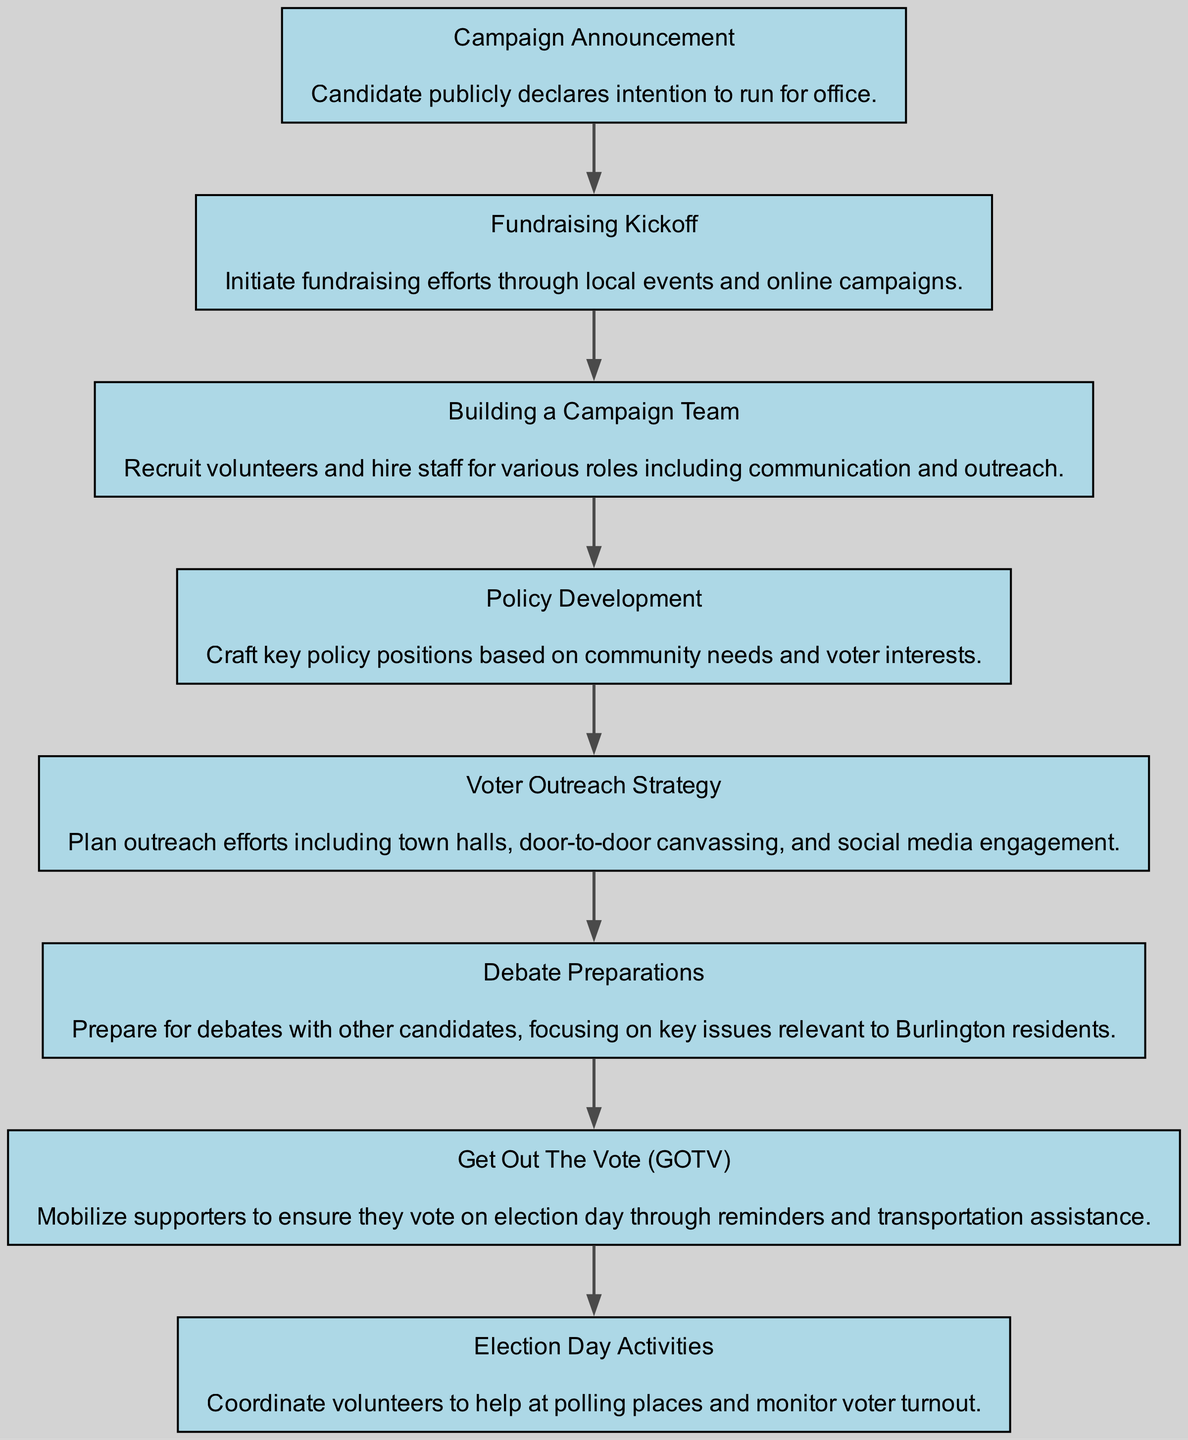What is the first stage in the campaign progression? The first stage listed in the diagram is "Campaign Announcement", which indicates the initial public declaration of the candidate's intention to run for office.
Answer: Campaign Announcement How many total stages are represented in the flow chart? By counting each stage from "Campaign Announcement" to "Election Day Activities," there are eight distinct stages shown in the diagram.
Answer: 8 What follows "Fundraising Kickoff" in the progression? The stage that comes immediately after "Fundraising Kickoff" is "Building a Campaign Team," indicating the transition from raising funds to assembling staff and volunteers for the campaign.
Answer: Building a Campaign Team What is the last stage before "Election Day Activities"? The last stage preceding "Election Day Activities" is "Get Out The Vote (GOTV)," which is focused on mobilizing supporters to ensure they participate in the election.
Answer: Get Out The Vote (GOTV) Which stage involves preparing for debates? The stage specifically dedicated to preparing candidates for debates is "Debate Preparations," highlighting the importance of engaging on key issues relevant to voters.
Answer: Debate Preparations What type of strategy is outlined in the stage following "Policy Development"? The stage that comes after "Policy Development" is "Voter Outreach Strategy," indicating that after policy crafting, efforts shift to engaging with voters through various outreach methods.
Answer: Voter Outreach Strategy Identify the action associated with "Get Out The Vote (GOTV)." The action associated with the "Get Out The Vote (GOTV)" stage involves mobilizing supporters to ensure they vote on election day through reminders and assistance with transportation.
Answer: Mobilize supporters What is described in the "Building a Campaign Team" stage? In the "Building a Campaign Team" stage, the focus is on recruiting volunteers and hiring staff, which is a critical part of preparing for the campaign's execution and outreach efforts.
Answer: Recruit volunteers and hire staff 